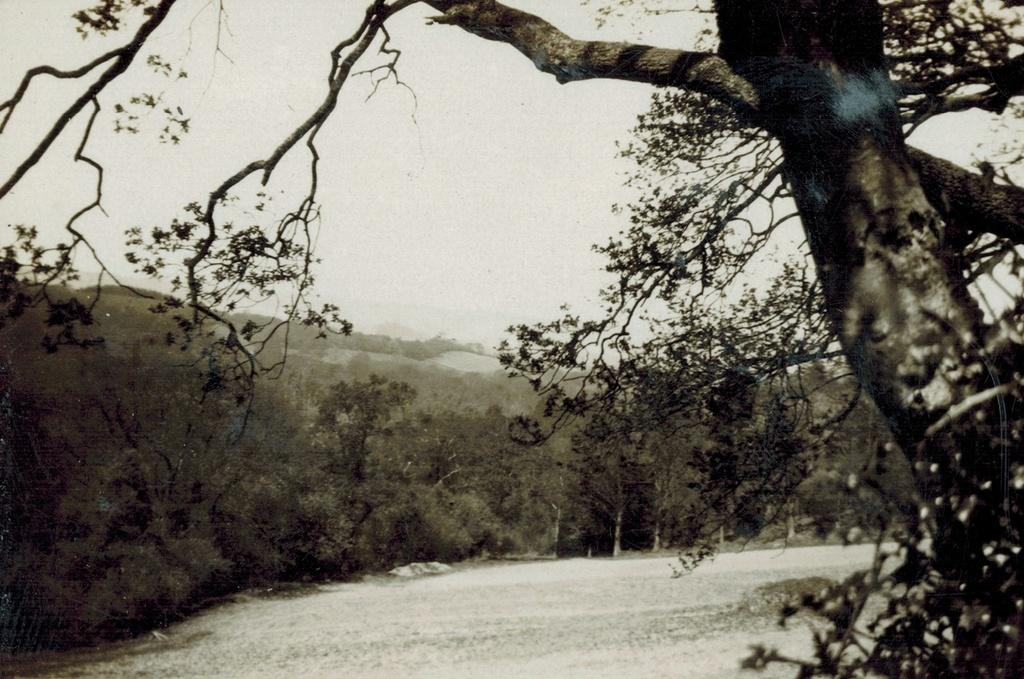What type of natural vegetation is visible in the image? There are trees in the image. What natural element is also visible in the image? There is water visible in the image. What part of the natural environment is visible in the image? The sky is visible in the image. What type of event is taking place in the image? There is no indication of any event taking place in the image. Can you identify any circular objects in the image? There is no circular object present in the image. Is there any quartz visible in the image? There is no quartz present in the image. 